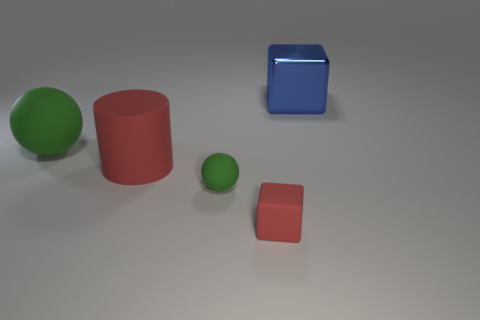Add 2 tiny yellow shiny spheres. How many objects exist? 7 Subtract all balls. How many objects are left? 3 Add 2 blue metal things. How many blue metal things are left? 3 Add 5 blocks. How many blocks exist? 7 Subtract 0 gray cylinders. How many objects are left? 5 Subtract all large shiny objects. Subtract all blue metallic things. How many objects are left? 3 